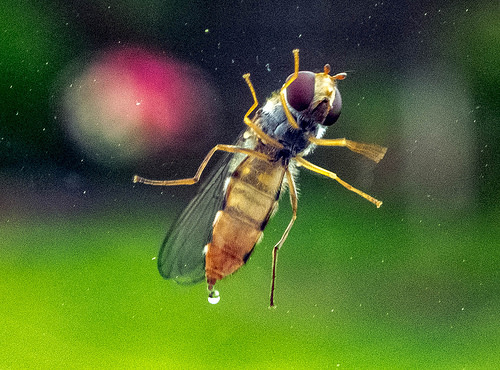<image>
Is the bug behind the window? Yes. From this viewpoint, the bug is positioned behind the window, with the window partially or fully occluding the bug. 